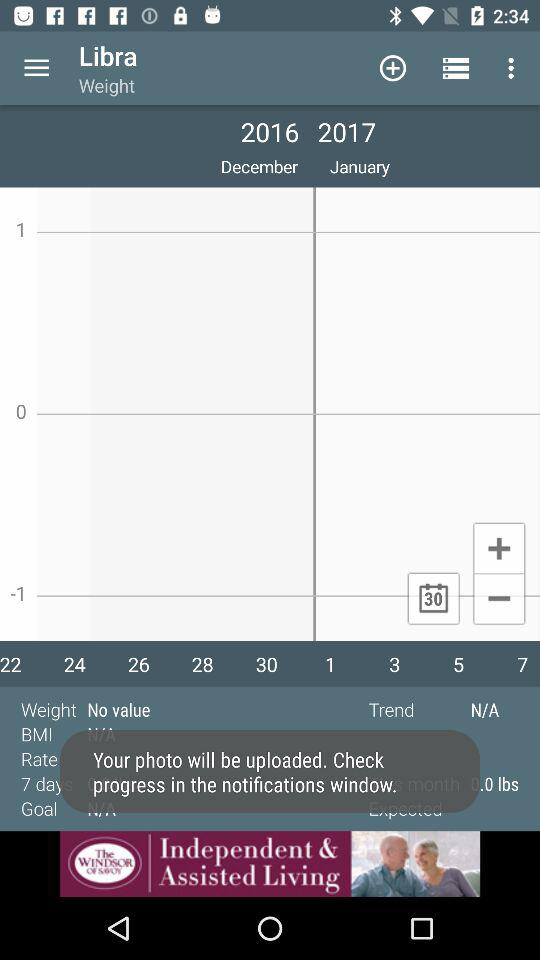What is the weight? There is no value in weight. 